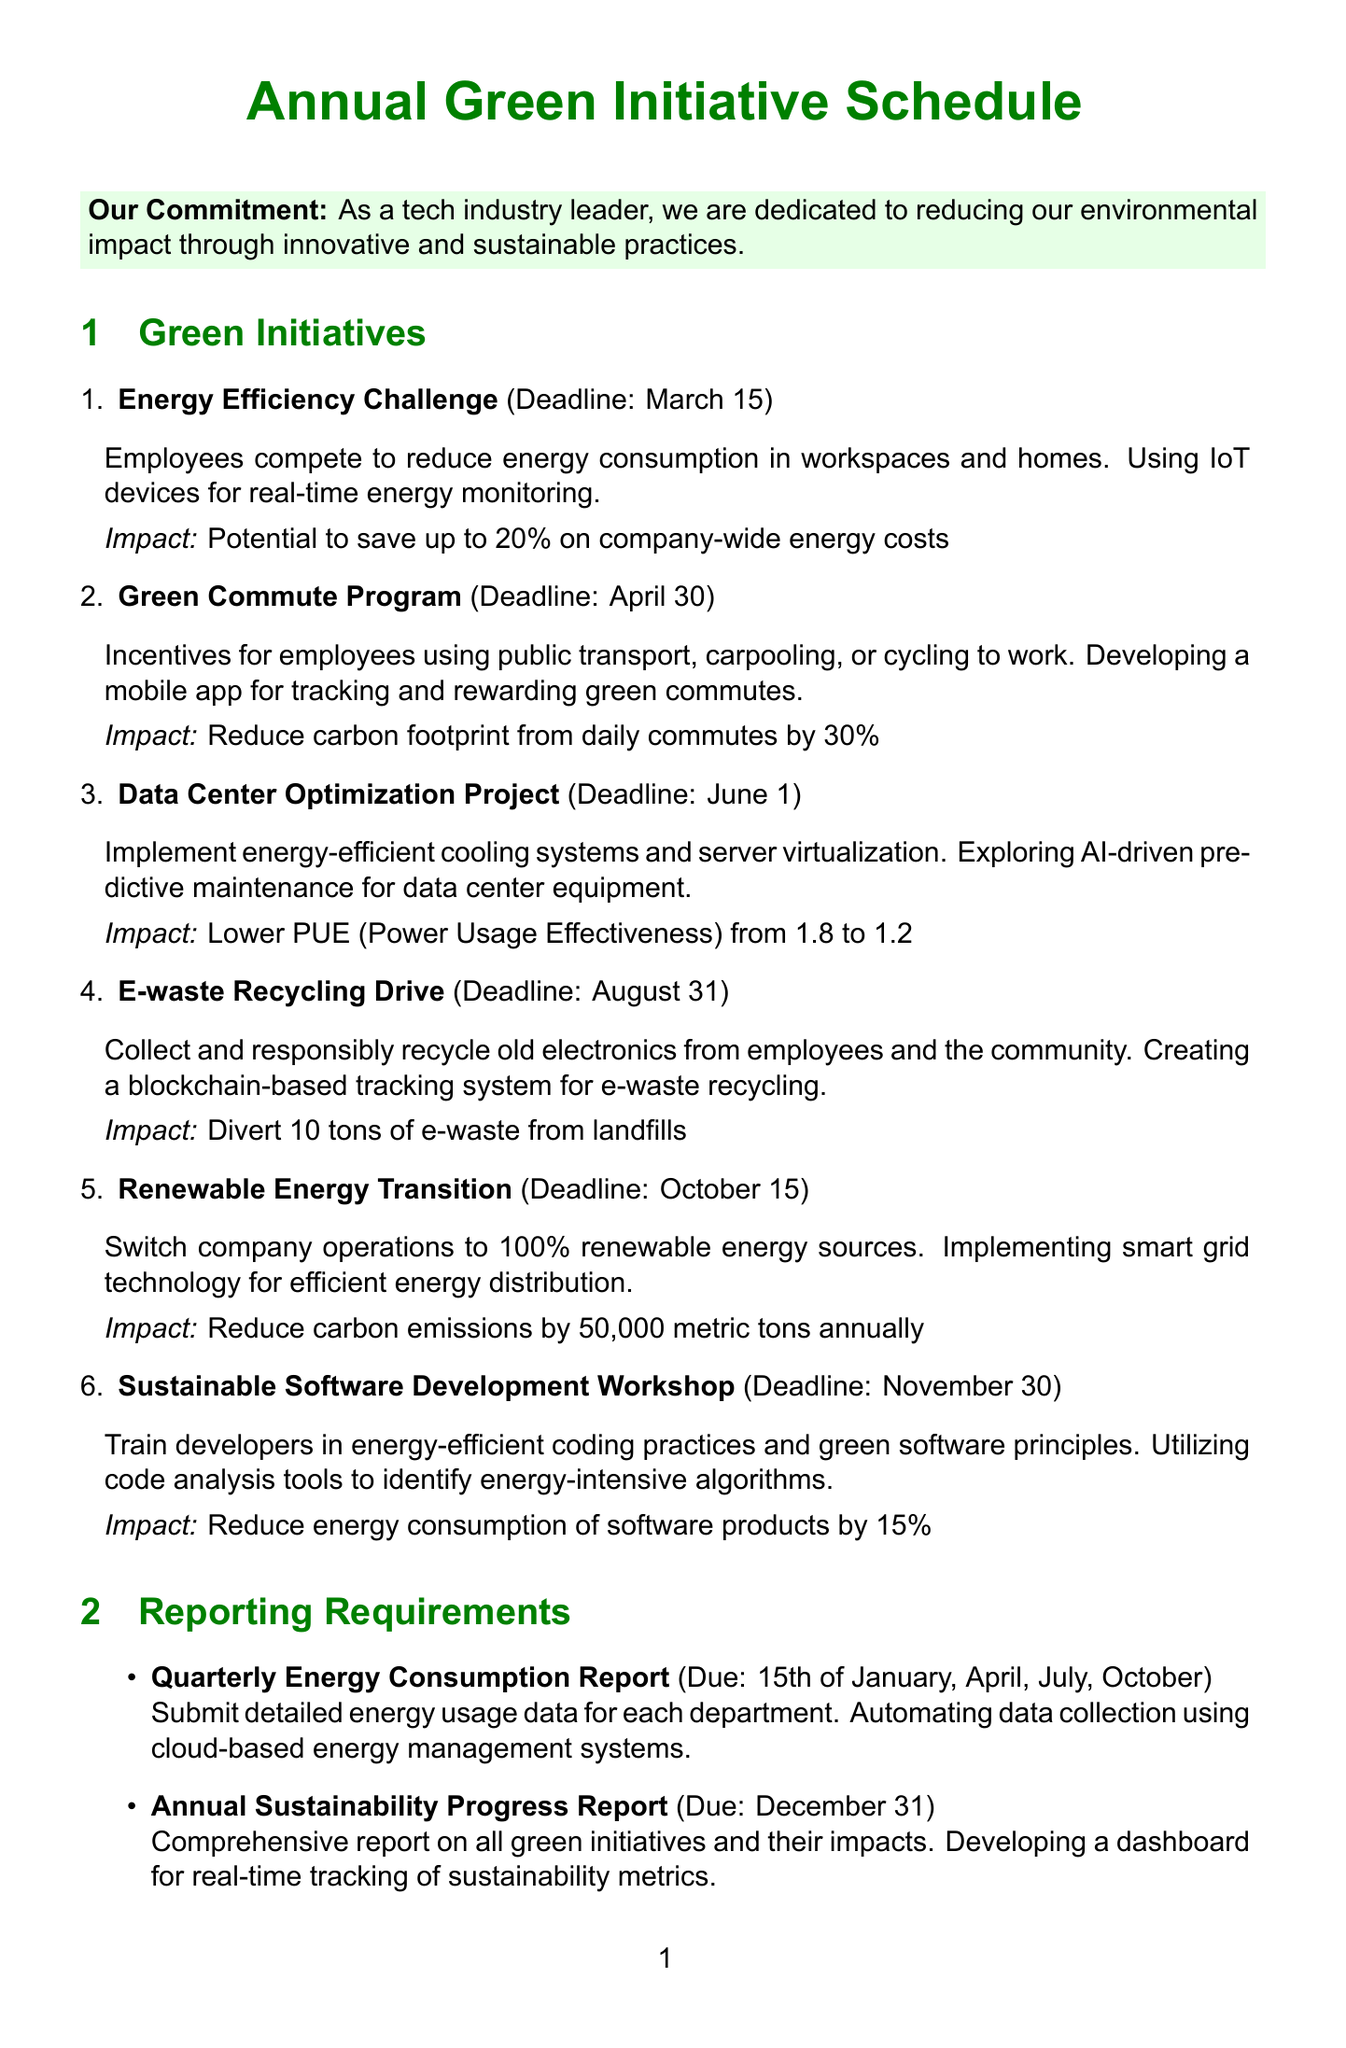What is the deadline for the Energy Efficiency Challenge? The deadline for the Energy Efficiency Challenge is clearly stated in the document as March 15.
Answer: March 15 What is the impact of the Green Commute Program? The document specifies that the Green Commute Program aims to reduce the carbon footprint from daily commutes by 30%.
Answer: Reduce carbon footprint by 30% When is the Annual Sustainability Progress Report due? The deadline for the Annual Sustainability Progress Report is mentioned in the document as December 31.
Answer: December 31 What technology focus is included in the E-waste Recycling Drive? The document describes the focus area of the E-waste Recycling Drive as creating a blockchain-based tracking system for e-waste recycling.
Answer: Blockchain-based tracking system How many tons of e-waste are targeted to be diverted from landfills? The document states that the E-waste Recycling Drive aims to divert 10 tons of e-waste from landfills.
Answer: 10 tons Which initiative has the earliest deadline? By reviewing the deadlines for all initiatives listed in the document, the earliest one is the Energy Efficiency Challenge.
Answer: Energy Efficiency Challenge What is the main goal of the Renewable Energy Transition? According to the document, the main goal of the Renewable Energy Transition is to switch company operations to 100% renewable energy sources.
Answer: 100% renewable energy sources What type of partnership is the Sustainable Technology Alliance? The document refers to the Sustainable Technology Alliance as a collaborative initiative with other tech companies on joint sustainability projects.
Answer: Collaborative initiative What is the reporting frequency for the Quarterly Energy Consumption Report? The document indicates that the Quarterly Energy Consumption Report is due on the 15th of January, April, July, and October.
Answer: Quarterly (15th of January, April, July, October) 